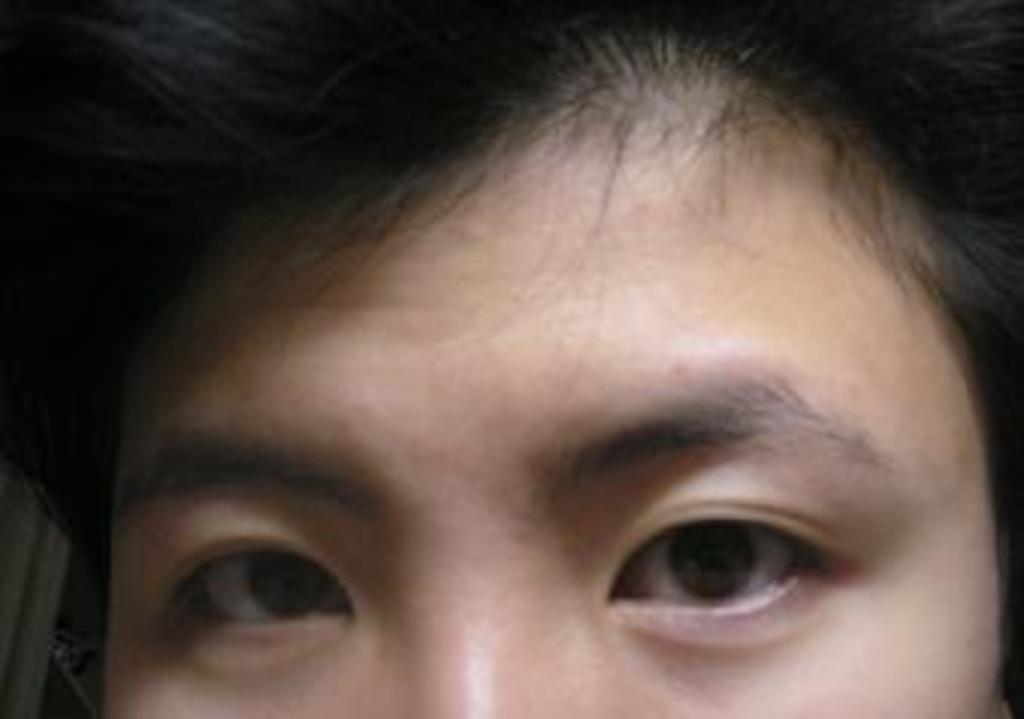In one or two sentences, can you explain what this image depicts? In this image I can see a person's face. This image is taken may be in a room. 